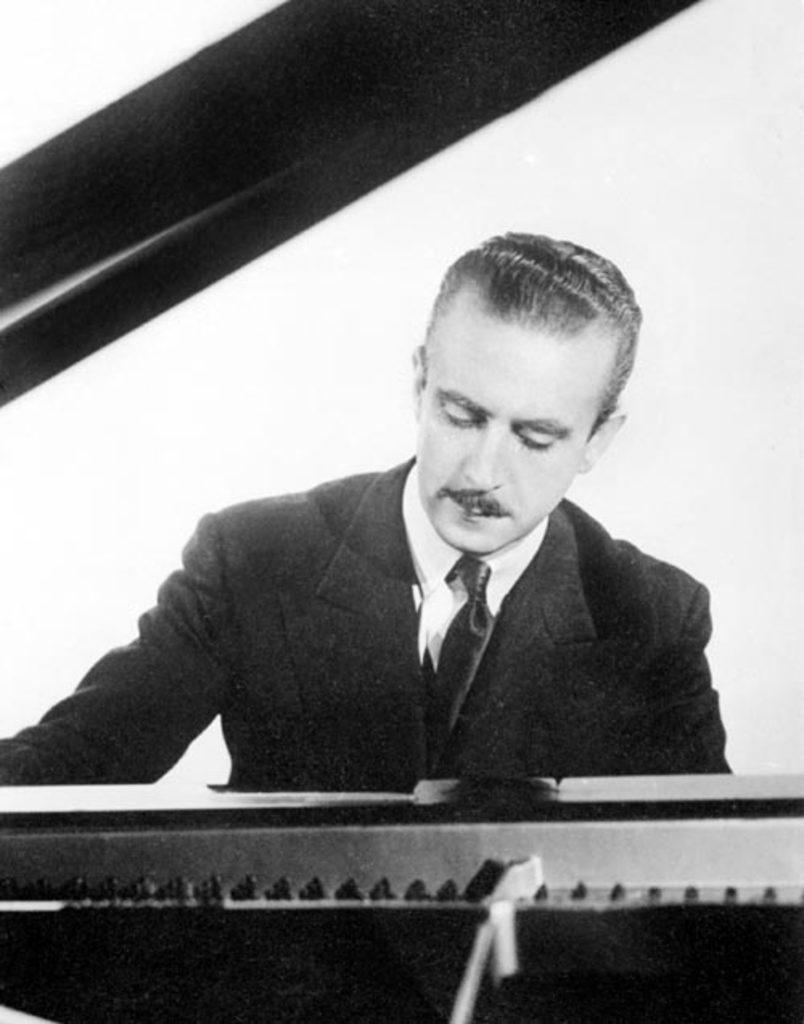What is the main subject of the image? The main subject of the image is a man sitting in the center of the image. What is the man doing in the image? The man is sitting in the image. What object is in front of the man? There is a musical instrument in front of the man. What type of copper material is being used by the man to help the group in the image? There is no copper material or group present in the image. 